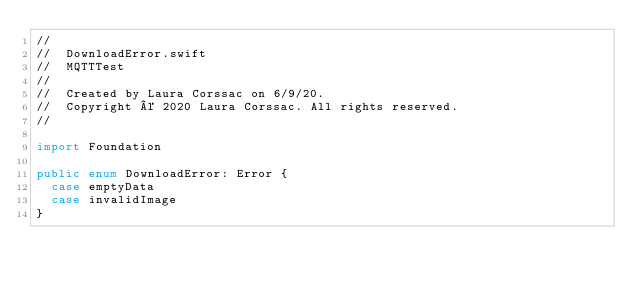Convert code to text. <code><loc_0><loc_0><loc_500><loc_500><_Swift_>//
//  DownloadError.swift
//  MQTTTest
//
//  Created by Laura Corssac on 6/9/20.
//  Copyright © 2020 Laura Corssac. All rights reserved.
//

import Foundation

public enum DownloadError: Error {
  case emptyData
  case invalidImage
}
</code> 